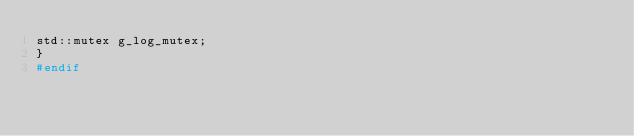<code> <loc_0><loc_0><loc_500><loc_500><_C++_>std::mutex g_log_mutex;
}
#endif
</code> 